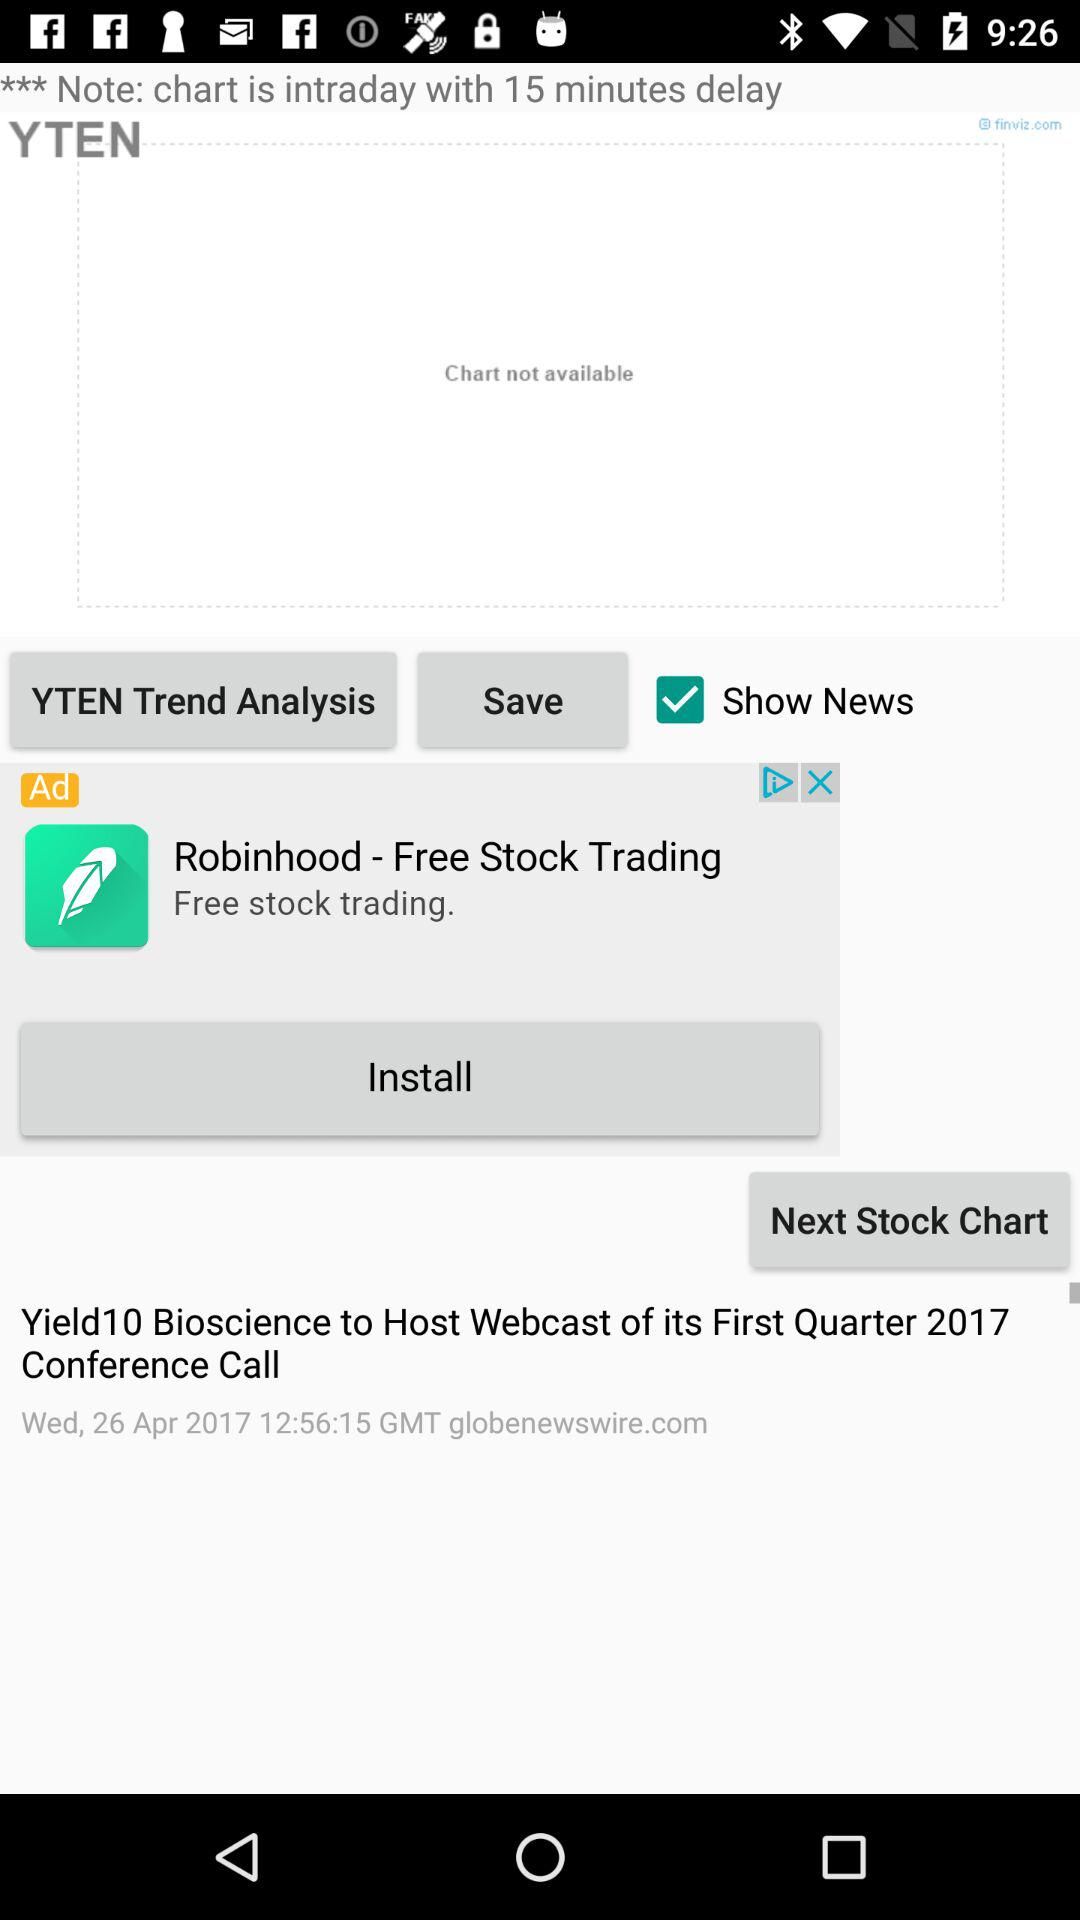When was the first quarter 2017 conference call of "Yield10 Bioscience" held? The first quarter 2017 conference call of "Yield10 Bioscience" was held on Wednesday, April 26, 2017 at 12:56:15 in Greenwich Mean Time. 